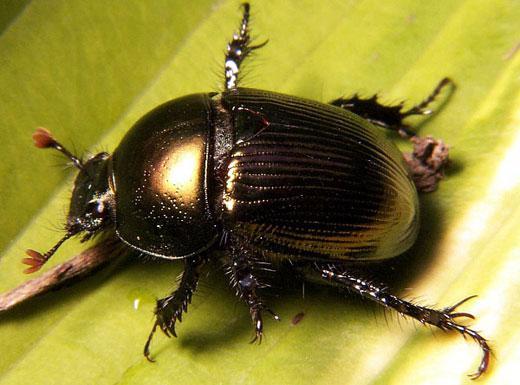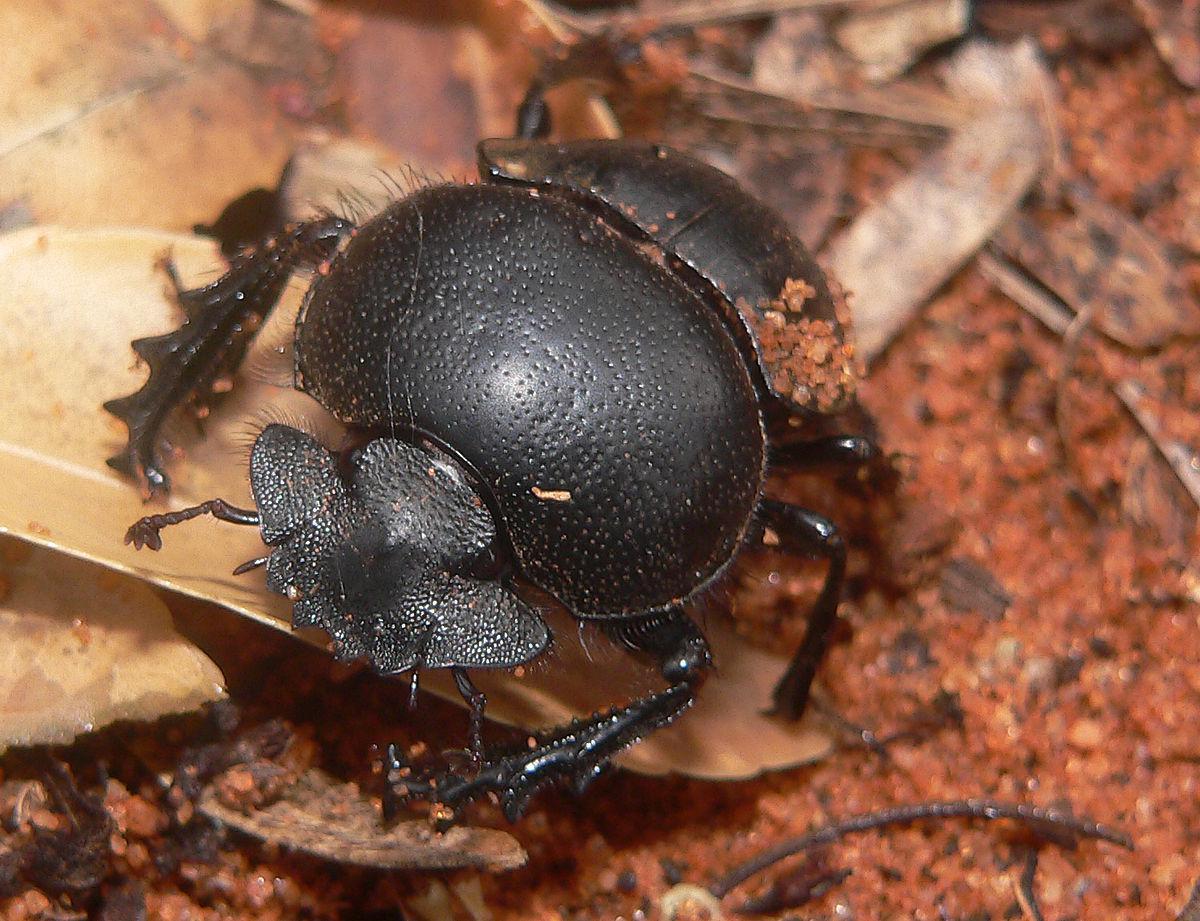The first image is the image on the left, the second image is the image on the right. For the images shown, is this caption "At least one beetle is in contact with a round, not oblong, ball." true? Answer yes or no. No. 